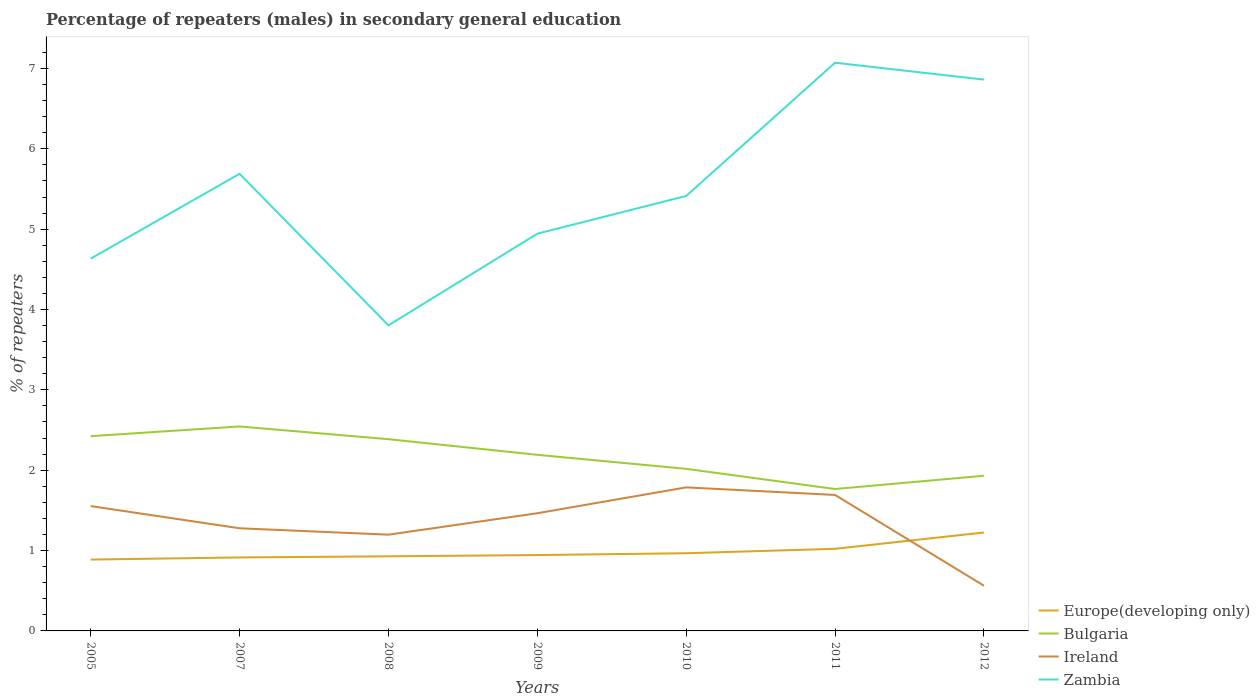How many different coloured lines are there?
Give a very brief answer. 4. Across all years, what is the maximum percentage of male repeaters in Bulgaria?
Your response must be concise. 1.77. In which year was the percentage of male repeaters in Bulgaria maximum?
Provide a short and direct response. 2011. What is the total percentage of male repeaters in Europe(developing only) in the graph?
Provide a short and direct response. -0.02. What is the difference between the highest and the second highest percentage of male repeaters in Europe(developing only)?
Ensure brevity in your answer.  0.34. Are the values on the major ticks of Y-axis written in scientific E-notation?
Offer a very short reply. No. Does the graph contain any zero values?
Keep it short and to the point. No. Where does the legend appear in the graph?
Provide a short and direct response. Bottom right. How many legend labels are there?
Provide a short and direct response. 4. How are the legend labels stacked?
Offer a very short reply. Vertical. What is the title of the graph?
Make the answer very short. Percentage of repeaters (males) in secondary general education. What is the label or title of the X-axis?
Provide a short and direct response. Years. What is the label or title of the Y-axis?
Your answer should be very brief. % of repeaters. What is the % of repeaters in Europe(developing only) in 2005?
Provide a short and direct response. 0.89. What is the % of repeaters of Bulgaria in 2005?
Keep it short and to the point. 2.42. What is the % of repeaters of Ireland in 2005?
Make the answer very short. 1.55. What is the % of repeaters in Zambia in 2005?
Provide a short and direct response. 4.63. What is the % of repeaters of Europe(developing only) in 2007?
Offer a terse response. 0.91. What is the % of repeaters of Bulgaria in 2007?
Your answer should be compact. 2.54. What is the % of repeaters of Ireland in 2007?
Ensure brevity in your answer.  1.28. What is the % of repeaters of Zambia in 2007?
Give a very brief answer. 5.69. What is the % of repeaters in Europe(developing only) in 2008?
Make the answer very short. 0.93. What is the % of repeaters in Bulgaria in 2008?
Keep it short and to the point. 2.39. What is the % of repeaters of Ireland in 2008?
Offer a terse response. 1.2. What is the % of repeaters in Zambia in 2008?
Give a very brief answer. 3.8. What is the % of repeaters in Europe(developing only) in 2009?
Provide a succinct answer. 0.94. What is the % of repeaters of Bulgaria in 2009?
Provide a succinct answer. 2.19. What is the % of repeaters of Ireland in 2009?
Your answer should be very brief. 1.46. What is the % of repeaters in Zambia in 2009?
Offer a very short reply. 4.94. What is the % of repeaters of Europe(developing only) in 2010?
Offer a very short reply. 0.97. What is the % of repeaters of Bulgaria in 2010?
Your response must be concise. 2.02. What is the % of repeaters in Ireland in 2010?
Make the answer very short. 1.79. What is the % of repeaters of Zambia in 2010?
Your response must be concise. 5.41. What is the % of repeaters in Europe(developing only) in 2011?
Offer a very short reply. 1.02. What is the % of repeaters of Bulgaria in 2011?
Your answer should be compact. 1.77. What is the % of repeaters of Ireland in 2011?
Your response must be concise. 1.69. What is the % of repeaters in Zambia in 2011?
Your answer should be compact. 7.07. What is the % of repeaters of Europe(developing only) in 2012?
Provide a short and direct response. 1.23. What is the % of repeaters of Bulgaria in 2012?
Your response must be concise. 1.93. What is the % of repeaters in Ireland in 2012?
Make the answer very short. 0.56. What is the % of repeaters in Zambia in 2012?
Make the answer very short. 6.86. Across all years, what is the maximum % of repeaters in Europe(developing only)?
Offer a very short reply. 1.23. Across all years, what is the maximum % of repeaters in Bulgaria?
Ensure brevity in your answer.  2.54. Across all years, what is the maximum % of repeaters of Ireland?
Give a very brief answer. 1.79. Across all years, what is the maximum % of repeaters of Zambia?
Your answer should be very brief. 7.07. Across all years, what is the minimum % of repeaters of Europe(developing only)?
Keep it short and to the point. 0.89. Across all years, what is the minimum % of repeaters in Bulgaria?
Keep it short and to the point. 1.77. Across all years, what is the minimum % of repeaters of Ireland?
Keep it short and to the point. 0.56. Across all years, what is the minimum % of repeaters in Zambia?
Ensure brevity in your answer.  3.8. What is the total % of repeaters in Europe(developing only) in the graph?
Your answer should be very brief. 6.89. What is the total % of repeaters in Bulgaria in the graph?
Offer a very short reply. 15.26. What is the total % of repeaters in Ireland in the graph?
Provide a short and direct response. 9.53. What is the total % of repeaters of Zambia in the graph?
Your answer should be very brief. 38.41. What is the difference between the % of repeaters of Europe(developing only) in 2005 and that in 2007?
Provide a short and direct response. -0.03. What is the difference between the % of repeaters of Bulgaria in 2005 and that in 2007?
Your response must be concise. -0.12. What is the difference between the % of repeaters of Ireland in 2005 and that in 2007?
Offer a terse response. 0.28. What is the difference between the % of repeaters in Zambia in 2005 and that in 2007?
Ensure brevity in your answer.  -1.06. What is the difference between the % of repeaters in Europe(developing only) in 2005 and that in 2008?
Give a very brief answer. -0.04. What is the difference between the % of repeaters in Bulgaria in 2005 and that in 2008?
Make the answer very short. 0.04. What is the difference between the % of repeaters in Ireland in 2005 and that in 2008?
Your response must be concise. 0.36. What is the difference between the % of repeaters in Zambia in 2005 and that in 2008?
Ensure brevity in your answer.  0.83. What is the difference between the % of repeaters of Europe(developing only) in 2005 and that in 2009?
Your answer should be very brief. -0.06. What is the difference between the % of repeaters of Bulgaria in 2005 and that in 2009?
Provide a short and direct response. 0.23. What is the difference between the % of repeaters of Ireland in 2005 and that in 2009?
Offer a terse response. 0.09. What is the difference between the % of repeaters of Zambia in 2005 and that in 2009?
Provide a succinct answer. -0.31. What is the difference between the % of repeaters in Europe(developing only) in 2005 and that in 2010?
Offer a terse response. -0.08. What is the difference between the % of repeaters in Bulgaria in 2005 and that in 2010?
Your answer should be compact. 0.41. What is the difference between the % of repeaters of Ireland in 2005 and that in 2010?
Provide a succinct answer. -0.23. What is the difference between the % of repeaters of Zambia in 2005 and that in 2010?
Provide a succinct answer. -0.78. What is the difference between the % of repeaters of Europe(developing only) in 2005 and that in 2011?
Provide a short and direct response. -0.13. What is the difference between the % of repeaters of Bulgaria in 2005 and that in 2011?
Offer a very short reply. 0.66. What is the difference between the % of repeaters in Ireland in 2005 and that in 2011?
Provide a short and direct response. -0.14. What is the difference between the % of repeaters of Zambia in 2005 and that in 2011?
Provide a short and direct response. -2.44. What is the difference between the % of repeaters in Europe(developing only) in 2005 and that in 2012?
Your answer should be very brief. -0.34. What is the difference between the % of repeaters in Bulgaria in 2005 and that in 2012?
Offer a very short reply. 0.49. What is the difference between the % of repeaters of Zambia in 2005 and that in 2012?
Your answer should be very brief. -2.23. What is the difference between the % of repeaters of Europe(developing only) in 2007 and that in 2008?
Your answer should be very brief. -0.01. What is the difference between the % of repeaters in Bulgaria in 2007 and that in 2008?
Ensure brevity in your answer.  0.16. What is the difference between the % of repeaters of Ireland in 2007 and that in 2008?
Your response must be concise. 0.08. What is the difference between the % of repeaters in Zambia in 2007 and that in 2008?
Make the answer very short. 1.89. What is the difference between the % of repeaters of Europe(developing only) in 2007 and that in 2009?
Give a very brief answer. -0.03. What is the difference between the % of repeaters in Bulgaria in 2007 and that in 2009?
Make the answer very short. 0.35. What is the difference between the % of repeaters of Ireland in 2007 and that in 2009?
Your answer should be very brief. -0.19. What is the difference between the % of repeaters in Zambia in 2007 and that in 2009?
Give a very brief answer. 0.75. What is the difference between the % of repeaters in Europe(developing only) in 2007 and that in 2010?
Your answer should be very brief. -0.05. What is the difference between the % of repeaters of Bulgaria in 2007 and that in 2010?
Your answer should be compact. 0.53. What is the difference between the % of repeaters in Ireland in 2007 and that in 2010?
Give a very brief answer. -0.51. What is the difference between the % of repeaters in Zambia in 2007 and that in 2010?
Provide a succinct answer. 0.28. What is the difference between the % of repeaters of Europe(developing only) in 2007 and that in 2011?
Give a very brief answer. -0.11. What is the difference between the % of repeaters in Bulgaria in 2007 and that in 2011?
Your answer should be compact. 0.78. What is the difference between the % of repeaters of Ireland in 2007 and that in 2011?
Your answer should be compact. -0.41. What is the difference between the % of repeaters in Zambia in 2007 and that in 2011?
Your response must be concise. -1.38. What is the difference between the % of repeaters in Europe(developing only) in 2007 and that in 2012?
Provide a short and direct response. -0.31. What is the difference between the % of repeaters of Bulgaria in 2007 and that in 2012?
Make the answer very short. 0.61. What is the difference between the % of repeaters in Ireland in 2007 and that in 2012?
Provide a succinct answer. 0.71. What is the difference between the % of repeaters in Zambia in 2007 and that in 2012?
Provide a succinct answer. -1.17. What is the difference between the % of repeaters of Europe(developing only) in 2008 and that in 2009?
Your answer should be very brief. -0.02. What is the difference between the % of repeaters in Bulgaria in 2008 and that in 2009?
Ensure brevity in your answer.  0.19. What is the difference between the % of repeaters of Ireland in 2008 and that in 2009?
Offer a very short reply. -0.27. What is the difference between the % of repeaters in Zambia in 2008 and that in 2009?
Provide a short and direct response. -1.14. What is the difference between the % of repeaters in Europe(developing only) in 2008 and that in 2010?
Your answer should be very brief. -0.04. What is the difference between the % of repeaters of Bulgaria in 2008 and that in 2010?
Keep it short and to the point. 0.37. What is the difference between the % of repeaters of Ireland in 2008 and that in 2010?
Provide a short and direct response. -0.59. What is the difference between the % of repeaters in Zambia in 2008 and that in 2010?
Provide a succinct answer. -1.61. What is the difference between the % of repeaters of Europe(developing only) in 2008 and that in 2011?
Your answer should be compact. -0.09. What is the difference between the % of repeaters of Bulgaria in 2008 and that in 2011?
Your response must be concise. 0.62. What is the difference between the % of repeaters in Ireland in 2008 and that in 2011?
Provide a short and direct response. -0.49. What is the difference between the % of repeaters of Zambia in 2008 and that in 2011?
Provide a short and direct response. -3.27. What is the difference between the % of repeaters of Europe(developing only) in 2008 and that in 2012?
Offer a terse response. -0.3. What is the difference between the % of repeaters of Bulgaria in 2008 and that in 2012?
Give a very brief answer. 0.46. What is the difference between the % of repeaters in Ireland in 2008 and that in 2012?
Your answer should be compact. 0.64. What is the difference between the % of repeaters in Zambia in 2008 and that in 2012?
Offer a terse response. -3.06. What is the difference between the % of repeaters of Europe(developing only) in 2009 and that in 2010?
Offer a terse response. -0.02. What is the difference between the % of repeaters of Bulgaria in 2009 and that in 2010?
Your answer should be compact. 0.17. What is the difference between the % of repeaters in Ireland in 2009 and that in 2010?
Ensure brevity in your answer.  -0.32. What is the difference between the % of repeaters in Zambia in 2009 and that in 2010?
Your answer should be very brief. -0.47. What is the difference between the % of repeaters in Europe(developing only) in 2009 and that in 2011?
Your answer should be compact. -0.08. What is the difference between the % of repeaters in Bulgaria in 2009 and that in 2011?
Provide a short and direct response. 0.43. What is the difference between the % of repeaters in Ireland in 2009 and that in 2011?
Make the answer very short. -0.23. What is the difference between the % of repeaters of Zambia in 2009 and that in 2011?
Give a very brief answer. -2.13. What is the difference between the % of repeaters in Europe(developing only) in 2009 and that in 2012?
Keep it short and to the point. -0.28. What is the difference between the % of repeaters of Bulgaria in 2009 and that in 2012?
Offer a very short reply. 0.26. What is the difference between the % of repeaters in Ireland in 2009 and that in 2012?
Make the answer very short. 0.9. What is the difference between the % of repeaters of Zambia in 2009 and that in 2012?
Make the answer very short. -1.92. What is the difference between the % of repeaters of Europe(developing only) in 2010 and that in 2011?
Provide a succinct answer. -0.05. What is the difference between the % of repeaters of Bulgaria in 2010 and that in 2011?
Make the answer very short. 0.25. What is the difference between the % of repeaters in Ireland in 2010 and that in 2011?
Give a very brief answer. 0.09. What is the difference between the % of repeaters in Zambia in 2010 and that in 2011?
Ensure brevity in your answer.  -1.66. What is the difference between the % of repeaters in Europe(developing only) in 2010 and that in 2012?
Offer a very short reply. -0.26. What is the difference between the % of repeaters of Bulgaria in 2010 and that in 2012?
Keep it short and to the point. 0.09. What is the difference between the % of repeaters in Ireland in 2010 and that in 2012?
Ensure brevity in your answer.  1.22. What is the difference between the % of repeaters of Zambia in 2010 and that in 2012?
Give a very brief answer. -1.45. What is the difference between the % of repeaters in Europe(developing only) in 2011 and that in 2012?
Provide a short and direct response. -0.2. What is the difference between the % of repeaters in Bulgaria in 2011 and that in 2012?
Your response must be concise. -0.16. What is the difference between the % of repeaters of Ireland in 2011 and that in 2012?
Give a very brief answer. 1.13. What is the difference between the % of repeaters of Zambia in 2011 and that in 2012?
Make the answer very short. 0.21. What is the difference between the % of repeaters of Europe(developing only) in 2005 and the % of repeaters of Bulgaria in 2007?
Your response must be concise. -1.66. What is the difference between the % of repeaters in Europe(developing only) in 2005 and the % of repeaters in Ireland in 2007?
Keep it short and to the point. -0.39. What is the difference between the % of repeaters in Europe(developing only) in 2005 and the % of repeaters in Zambia in 2007?
Ensure brevity in your answer.  -4.8. What is the difference between the % of repeaters of Bulgaria in 2005 and the % of repeaters of Ireland in 2007?
Make the answer very short. 1.15. What is the difference between the % of repeaters in Bulgaria in 2005 and the % of repeaters in Zambia in 2007?
Offer a very short reply. -3.26. What is the difference between the % of repeaters in Ireland in 2005 and the % of repeaters in Zambia in 2007?
Provide a short and direct response. -4.13. What is the difference between the % of repeaters of Europe(developing only) in 2005 and the % of repeaters of Bulgaria in 2008?
Your response must be concise. -1.5. What is the difference between the % of repeaters of Europe(developing only) in 2005 and the % of repeaters of Ireland in 2008?
Give a very brief answer. -0.31. What is the difference between the % of repeaters of Europe(developing only) in 2005 and the % of repeaters of Zambia in 2008?
Make the answer very short. -2.91. What is the difference between the % of repeaters of Bulgaria in 2005 and the % of repeaters of Ireland in 2008?
Your answer should be very brief. 1.23. What is the difference between the % of repeaters in Bulgaria in 2005 and the % of repeaters in Zambia in 2008?
Your answer should be very brief. -1.38. What is the difference between the % of repeaters in Ireland in 2005 and the % of repeaters in Zambia in 2008?
Ensure brevity in your answer.  -2.25. What is the difference between the % of repeaters in Europe(developing only) in 2005 and the % of repeaters in Bulgaria in 2009?
Keep it short and to the point. -1.3. What is the difference between the % of repeaters of Europe(developing only) in 2005 and the % of repeaters of Ireland in 2009?
Ensure brevity in your answer.  -0.58. What is the difference between the % of repeaters in Europe(developing only) in 2005 and the % of repeaters in Zambia in 2009?
Give a very brief answer. -4.06. What is the difference between the % of repeaters of Bulgaria in 2005 and the % of repeaters of Ireland in 2009?
Give a very brief answer. 0.96. What is the difference between the % of repeaters of Bulgaria in 2005 and the % of repeaters of Zambia in 2009?
Provide a succinct answer. -2.52. What is the difference between the % of repeaters of Ireland in 2005 and the % of repeaters of Zambia in 2009?
Your answer should be very brief. -3.39. What is the difference between the % of repeaters of Europe(developing only) in 2005 and the % of repeaters of Bulgaria in 2010?
Give a very brief answer. -1.13. What is the difference between the % of repeaters in Europe(developing only) in 2005 and the % of repeaters in Ireland in 2010?
Give a very brief answer. -0.9. What is the difference between the % of repeaters in Europe(developing only) in 2005 and the % of repeaters in Zambia in 2010?
Provide a short and direct response. -4.53. What is the difference between the % of repeaters in Bulgaria in 2005 and the % of repeaters in Ireland in 2010?
Your response must be concise. 0.64. What is the difference between the % of repeaters of Bulgaria in 2005 and the % of repeaters of Zambia in 2010?
Offer a very short reply. -2.99. What is the difference between the % of repeaters of Ireland in 2005 and the % of repeaters of Zambia in 2010?
Make the answer very short. -3.86. What is the difference between the % of repeaters in Europe(developing only) in 2005 and the % of repeaters in Bulgaria in 2011?
Provide a short and direct response. -0.88. What is the difference between the % of repeaters of Europe(developing only) in 2005 and the % of repeaters of Ireland in 2011?
Your response must be concise. -0.8. What is the difference between the % of repeaters in Europe(developing only) in 2005 and the % of repeaters in Zambia in 2011?
Your answer should be compact. -6.18. What is the difference between the % of repeaters in Bulgaria in 2005 and the % of repeaters in Ireland in 2011?
Offer a terse response. 0.73. What is the difference between the % of repeaters of Bulgaria in 2005 and the % of repeaters of Zambia in 2011?
Give a very brief answer. -4.65. What is the difference between the % of repeaters of Ireland in 2005 and the % of repeaters of Zambia in 2011?
Make the answer very short. -5.52. What is the difference between the % of repeaters in Europe(developing only) in 2005 and the % of repeaters in Bulgaria in 2012?
Keep it short and to the point. -1.04. What is the difference between the % of repeaters of Europe(developing only) in 2005 and the % of repeaters of Ireland in 2012?
Your answer should be very brief. 0.33. What is the difference between the % of repeaters in Europe(developing only) in 2005 and the % of repeaters in Zambia in 2012?
Your answer should be very brief. -5.97. What is the difference between the % of repeaters of Bulgaria in 2005 and the % of repeaters of Ireland in 2012?
Give a very brief answer. 1.86. What is the difference between the % of repeaters of Bulgaria in 2005 and the % of repeaters of Zambia in 2012?
Your response must be concise. -4.44. What is the difference between the % of repeaters in Ireland in 2005 and the % of repeaters in Zambia in 2012?
Provide a short and direct response. -5.31. What is the difference between the % of repeaters in Europe(developing only) in 2007 and the % of repeaters in Bulgaria in 2008?
Make the answer very short. -1.47. What is the difference between the % of repeaters in Europe(developing only) in 2007 and the % of repeaters in Ireland in 2008?
Keep it short and to the point. -0.28. What is the difference between the % of repeaters in Europe(developing only) in 2007 and the % of repeaters in Zambia in 2008?
Offer a terse response. -2.89. What is the difference between the % of repeaters in Bulgaria in 2007 and the % of repeaters in Ireland in 2008?
Offer a very short reply. 1.35. What is the difference between the % of repeaters of Bulgaria in 2007 and the % of repeaters of Zambia in 2008?
Offer a very short reply. -1.26. What is the difference between the % of repeaters of Ireland in 2007 and the % of repeaters of Zambia in 2008?
Your response must be concise. -2.53. What is the difference between the % of repeaters of Europe(developing only) in 2007 and the % of repeaters of Bulgaria in 2009?
Offer a very short reply. -1.28. What is the difference between the % of repeaters of Europe(developing only) in 2007 and the % of repeaters of Ireland in 2009?
Provide a short and direct response. -0.55. What is the difference between the % of repeaters of Europe(developing only) in 2007 and the % of repeaters of Zambia in 2009?
Provide a succinct answer. -4.03. What is the difference between the % of repeaters of Bulgaria in 2007 and the % of repeaters of Zambia in 2009?
Ensure brevity in your answer.  -2.4. What is the difference between the % of repeaters of Ireland in 2007 and the % of repeaters of Zambia in 2009?
Ensure brevity in your answer.  -3.67. What is the difference between the % of repeaters in Europe(developing only) in 2007 and the % of repeaters in Bulgaria in 2010?
Provide a succinct answer. -1.1. What is the difference between the % of repeaters of Europe(developing only) in 2007 and the % of repeaters of Ireland in 2010?
Offer a terse response. -0.87. What is the difference between the % of repeaters of Europe(developing only) in 2007 and the % of repeaters of Zambia in 2010?
Provide a short and direct response. -4.5. What is the difference between the % of repeaters in Bulgaria in 2007 and the % of repeaters in Ireland in 2010?
Offer a very short reply. 0.76. What is the difference between the % of repeaters of Bulgaria in 2007 and the % of repeaters of Zambia in 2010?
Your response must be concise. -2.87. What is the difference between the % of repeaters of Ireland in 2007 and the % of repeaters of Zambia in 2010?
Keep it short and to the point. -4.14. What is the difference between the % of repeaters in Europe(developing only) in 2007 and the % of repeaters in Bulgaria in 2011?
Keep it short and to the point. -0.85. What is the difference between the % of repeaters in Europe(developing only) in 2007 and the % of repeaters in Ireland in 2011?
Your answer should be very brief. -0.78. What is the difference between the % of repeaters of Europe(developing only) in 2007 and the % of repeaters of Zambia in 2011?
Make the answer very short. -6.16. What is the difference between the % of repeaters in Bulgaria in 2007 and the % of repeaters in Ireland in 2011?
Your response must be concise. 0.85. What is the difference between the % of repeaters of Bulgaria in 2007 and the % of repeaters of Zambia in 2011?
Provide a short and direct response. -4.53. What is the difference between the % of repeaters of Ireland in 2007 and the % of repeaters of Zambia in 2011?
Your answer should be compact. -5.79. What is the difference between the % of repeaters in Europe(developing only) in 2007 and the % of repeaters in Bulgaria in 2012?
Offer a very short reply. -1.02. What is the difference between the % of repeaters of Europe(developing only) in 2007 and the % of repeaters of Ireland in 2012?
Offer a terse response. 0.35. What is the difference between the % of repeaters of Europe(developing only) in 2007 and the % of repeaters of Zambia in 2012?
Provide a succinct answer. -5.95. What is the difference between the % of repeaters in Bulgaria in 2007 and the % of repeaters in Ireland in 2012?
Provide a succinct answer. 1.98. What is the difference between the % of repeaters in Bulgaria in 2007 and the % of repeaters in Zambia in 2012?
Make the answer very short. -4.32. What is the difference between the % of repeaters in Ireland in 2007 and the % of repeaters in Zambia in 2012?
Provide a succinct answer. -5.58. What is the difference between the % of repeaters of Europe(developing only) in 2008 and the % of repeaters of Bulgaria in 2009?
Provide a short and direct response. -1.26. What is the difference between the % of repeaters of Europe(developing only) in 2008 and the % of repeaters of Ireland in 2009?
Your response must be concise. -0.54. What is the difference between the % of repeaters of Europe(developing only) in 2008 and the % of repeaters of Zambia in 2009?
Offer a terse response. -4.01. What is the difference between the % of repeaters in Bulgaria in 2008 and the % of repeaters in Ireland in 2009?
Provide a succinct answer. 0.92. What is the difference between the % of repeaters of Bulgaria in 2008 and the % of repeaters of Zambia in 2009?
Offer a very short reply. -2.56. What is the difference between the % of repeaters in Ireland in 2008 and the % of repeaters in Zambia in 2009?
Your answer should be compact. -3.75. What is the difference between the % of repeaters of Europe(developing only) in 2008 and the % of repeaters of Bulgaria in 2010?
Your response must be concise. -1.09. What is the difference between the % of repeaters of Europe(developing only) in 2008 and the % of repeaters of Ireland in 2010?
Offer a very short reply. -0.86. What is the difference between the % of repeaters in Europe(developing only) in 2008 and the % of repeaters in Zambia in 2010?
Keep it short and to the point. -4.48. What is the difference between the % of repeaters in Bulgaria in 2008 and the % of repeaters in Ireland in 2010?
Your response must be concise. 0.6. What is the difference between the % of repeaters of Bulgaria in 2008 and the % of repeaters of Zambia in 2010?
Provide a short and direct response. -3.03. What is the difference between the % of repeaters of Ireland in 2008 and the % of repeaters of Zambia in 2010?
Your response must be concise. -4.22. What is the difference between the % of repeaters in Europe(developing only) in 2008 and the % of repeaters in Bulgaria in 2011?
Your answer should be compact. -0.84. What is the difference between the % of repeaters in Europe(developing only) in 2008 and the % of repeaters in Ireland in 2011?
Offer a terse response. -0.76. What is the difference between the % of repeaters in Europe(developing only) in 2008 and the % of repeaters in Zambia in 2011?
Keep it short and to the point. -6.14. What is the difference between the % of repeaters of Bulgaria in 2008 and the % of repeaters of Ireland in 2011?
Your response must be concise. 0.69. What is the difference between the % of repeaters of Bulgaria in 2008 and the % of repeaters of Zambia in 2011?
Your response must be concise. -4.68. What is the difference between the % of repeaters in Ireland in 2008 and the % of repeaters in Zambia in 2011?
Ensure brevity in your answer.  -5.87. What is the difference between the % of repeaters in Europe(developing only) in 2008 and the % of repeaters in Bulgaria in 2012?
Make the answer very short. -1. What is the difference between the % of repeaters of Europe(developing only) in 2008 and the % of repeaters of Ireland in 2012?
Give a very brief answer. 0.37. What is the difference between the % of repeaters of Europe(developing only) in 2008 and the % of repeaters of Zambia in 2012?
Provide a succinct answer. -5.93. What is the difference between the % of repeaters in Bulgaria in 2008 and the % of repeaters in Ireland in 2012?
Give a very brief answer. 1.82. What is the difference between the % of repeaters in Bulgaria in 2008 and the % of repeaters in Zambia in 2012?
Offer a terse response. -4.47. What is the difference between the % of repeaters of Ireland in 2008 and the % of repeaters of Zambia in 2012?
Offer a terse response. -5.66. What is the difference between the % of repeaters of Europe(developing only) in 2009 and the % of repeaters of Bulgaria in 2010?
Offer a very short reply. -1.07. What is the difference between the % of repeaters of Europe(developing only) in 2009 and the % of repeaters of Ireland in 2010?
Provide a short and direct response. -0.84. What is the difference between the % of repeaters in Europe(developing only) in 2009 and the % of repeaters in Zambia in 2010?
Provide a succinct answer. -4.47. What is the difference between the % of repeaters in Bulgaria in 2009 and the % of repeaters in Ireland in 2010?
Your answer should be compact. 0.41. What is the difference between the % of repeaters of Bulgaria in 2009 and the % of repeaters of Zambia in 2010?
Give a very brief answer. -3.22. What is the difference between the % of repeaters in Ireland in 2009 and the % of repeaters in Zambia in 2010?
Offer a terse response. -3.95. What is the difference between the % of repeaters of Europe(developing only) in 2009 and the % of repeaters of Bulgaria in 2011?
Provide a short and direct response. -0.82. What is the difference between the % of repeaters in Europe(developing only) in 2009 and the % of repeaters in Ireland in 2011?
Provide a short and direct response. -0.75. What is the difference between the % of repeaters of Europe(developing only) in 2009 and the % of repeaters of Zambia in 2011?
Provide a succinct answer. -6.13. What is the difference between the % of repeaters in Bulgaria in 2009 and the % of repeaters in Ireland in 2011?
Offer a very short reply. 0.5. What is the difference between the % of repeaters in Bulgaria in 2009 and the % of repeaters in Zambia in 2011?
Your answer should be compact. -4.88. What is the difference between the % of repeaters of Ireland in 2009 and the % of repeaters of Zambia in 2011?
Offer a terse response. -5.61. What is the difference between the % of repeaters of Europe(developing only) in 2009 and the % of repeaters of Bulgaria in 2012?
Your answer should be compact. -0.99. What is the difference between the % of repeaters in Europe(developing only) in 2009 and the % of repeaters in Ireland in 2012?
Your answer should be compact. 0.38. What is the difference between the % of repeaters in Europe(developing only) in 2009 and the % of repeaters in Zambia in 2012?
Provide a short and direct response. -5.92. What is the difference between the % of repeaters in Bulgaria in 2009 and the % of repeaters in Ireland in 2012?
Offer a terse response. 1.63. What is the difference between the % of repeaters in Bulgaria in 2009 and the % of repeaters in Zambia in 2012?
Provide a succinct answer. -4.67. What is the difference between the % of repeaters of Ireland in 2009 and the % of repeaters of Zambia in 2012?
Your answer should be very brief. -5.4. What is the difference between the % of repeaters of Europe(developing only) in 2010 and the % of repeaters of Bulgaria in 2011?
Your answer should be very brief. -0.8. What is the difference between the % of repeaters in Europe(developing only) in 2010 and the % of repeaters in Ireland in 2011?
Provide a succinct answer. -0.73. What is the difference between the % of repeaters in Europe(developing only) in 2010 and the % of repeaters in Zambia in 2011?
Provide a short and direct response. -6.1. What is the difference between the % of repeaters in Bulgaria in 2010 and the % of repeaters in Ireland in 2011?
Provide a short and direct response. 0.33. What is the difference between the % of repeaters of Bulgaria in 2010 and the % of repeaters of Zambia in 2011?
Your answer should be compact. -5.05. What is the difference between the % of repeaters of Ireland in 2010 and the % of repeaters of Zambia in 2011?
Keep it short and to the point. -5.28. What is the difference between the % of repeaters of Europe(developing only) in 2010 and the % of repeaters of Bulgaria in 2012?
Your answer should be compact. -0.96. What is the difference between the % of repeaters in Europe(developing only) in 2010 and the % of repeaters in Ireland in 2012?
Your answer should be compact. 0.4. What is the difference between the % of repeaters in Europe(developing only) in 2010 and the % of repeaters in Zambia in 2012?
Ensure brevity in your answer.  -5.89. What is the difference between the % of repeaters in Bulgaria in 2010 and the % of repeaters in Ireland in 2012?
Provide a short and direct response. 1.45. What is the difference between the % of repeaters of Bulgaria in 2010 and the % of repeaters of Zambia in 2012?
Your answer should be very brief. -4.84. What is the difference between the % of repeaters in Ireland in 2010 and the % of repeaters in Zambia in 2012?
Offer a very short reply. -5.07. What is the difference between the % of repeaters in Europe(developing only) in 2011 and the % of repeaters in Bulgaria in 2012?
Provide a succinct answer. -0.91. What is the difference between the % of repeaters of Europe(developing only) in 2011 and the % of repeaters of Ireland in 2012?
Offer a terse response. 0.46. What is the difference between the % of repeaters of Europe(developing only) in 2011 and the % of repeaters of Zambia in 2012?
Offer a very short reply. -5.84. What is the difference between the % of repeaters of Bulgaria in 2011 and the % of repeaters of Ireland in 2012?
Provide a succinct answer. 1.2. What is the difference between the % of repeaters of Bulgaria in 2011 and the % of repeaters of Zambia in 2012?
Make the answer very short. -5.09. What is the difference between the % of repeaters in Ireland in 2011 and the % of repeaters in Zambia in 2012?
Give a very brief answer. -5.17. What is the average % of repeaters of Europe(developing only) per year?
Keep it short and to the point. 0.98. What is the average % of repeaters of Bulgaria per year?
Offer a terse response. 2.18. What is the average % of repeaters of Ireland per year?
Ensure brevity in your answer.  1.36. What is the average % of repeaters of Zambia per year?
Your answer should be very brief. 5.49. In the year 2005, what is the difference between the % of repeaters of Europe(developing only) and % of repeaters of Bulgaria?
Your answer should be very brief. -1.54. In the year 2005, what is the difference between the % of repeaters of Europe(developing only) and % of repeaters of Ireland?
Offer a terse response. -0.67. In the year 2005, what is the difference between the % of repeaters of Europe(developing only) and % of repeaters of Zambia?
Offer a terse response. -3.75. In the year 2005, what is the difference between the % of repeaters of Bulgaria and % of repeaters of Ireland?
Make the answer very short. 0.87. In the year 2005, what is the difference between the % of repeaters of Bulgaria and % of repeaters of Zambia?
Your answer should be very brief. -2.21. In the year 2005, what is the difference between the % of repeaters of Ireland and % of repeaters of Zambia?
Give a very brief answer. -3.08. In the year 2007, what is the difference between the % of repeaters in Europe(developing only) and % of repeaters in Bulgaria?
Offer a terse response. -1.63. In the year 2007, what is the difference between the % of repeaters in Europe(developing only) and % of repeaters in Ireland?
Give a very brief answer. -0.36. In the year 2007, what is the difference between the % of repeaters in Europe(developing only) and % of repeaters in Zambia?
Your response must be concise. -4.77. In the year 2007, what is the difference between the % of repeaters in Bulgaria and % of repeaters in Ireland?
Make the answer very short. 1.27. In the year 2007, what is the difference between the % of repeaters of Bulgaria and % of repeaters of Zambia?
Provide a short and direct response. -3.14. In the year 2007, what is the difference between the % of repeaters of Ireland and % of repeaters of Zambia?
Offer a very short reply. -4.41. In the year 2008, what is the difference between the % of repeaters in Europe(developing only) and % of repeaters in Bulgaria?
Give a very brief answer. -1.46. In the year 2008, what is the difference between the % of repeaters of Europe(developing only) and % of repeaters of Ireland?
Give a very brief answer. -0.27. In the year 2008, what is the difference between the % of repeaters in Europe(developing only) and % of repeaters in Zambia?
Your response must be concise. -2.87. In the year 2008, what is the difference between the % of repeaters of Bulgaria and % of repeaters of Ireland?
Your response must be concise. 1.19. In the year 2008, what is the difference between the % of repeaters in Bulgaria and % of repeaters in Zambia?
Give a very brief answer. -1.42. In the year 2008, what is the difference between the % of repeaters in Ireland and % of repeaters in Zambia?
Offer a very short reply. -2.6. In the year 2009, what is the difference between the % of repeaters in Europe(developing only) and % of repeaters in Bulgaria?
Offer a very short reply. -1.25. In the year 2009, what is the difference between the % of repeaters of Europe(developing only) and % of repeaters of Ireland?
Ensure brevity in your answer.  -0.52. In the year 2009, what is the difference between the % of repeaters of Europe(developing only) and % of repeaters of Zambia?
Your answer should be compact. -4. In the year 2009, what is the difference between the % of repeaters in Bulgaria and % of repeaters in Ireland?
Make the answer very short. 0.73. In the year 2009, what is the difference between the % of repeaters of Bulgaria and % of repeaters of Zambia?
Provide a short and direct response. -2.75. In the year 2009, what is the difference between the % of repeaters of Ireland and % of repeaters of Zambia?
Offer a terse response. -3.48. In the year 2010, what is the difference between the % of repeaters in Europe(developing only) and % of repeaters in Bulgaria?
Give a very brief answer. -1.05. In the year 2010, what is the difference between the % of repeaters in Europe(developing only) and % of repeaters in Ireland?
Your response must be concise. -0.82. In the year 2010, what is the difference between the % of repeaters in Europe(developing only) and % of repeaters in Zambia?
Your response must be concise. -4.45. In the year 2010, what is the difference between the % of repeaters in Bulgaria and % of repeaters in Ireland?
Your answer should be very brief. 0.23. In the year 2010, what is the difference between the % of repeaters in Bulgaria and % of repeaters in Zambia?
Ensure brevity in your answer.  -3.4. In the year 2010, what is the difference between the % of repeaters in Ireland and % of repeaters in Zambia?
Keep it short and to the point. -3.63. In the year 2011, what is the difference between the % of repeaters of Europe(developing only) and % of repeaters of Bulgaria?
Keep it short and to the point. -0.74. In the year 2011, what is the difference between the % of repeaters in Europe(developing only) and % of repeaters in Ireland?
Make the answer very short. -0.67. In the year 2011, what is the difference between the % of repeaters of Europe(developing only) and % of repeaters of Zambia?
Your response must be concise. -6.05. In the year 2011, what is the difference between the % of repeaters in Bulgaria and % of repeaters in Ireland?
Offer a terse response. 0.07. In the year 2011, what is the difference between the % of repeaters in Bulgaria and % of repeaters in Zambia?
Ensure brevity in your answer.  -5.3. In the year 2011, what is the difference between the % of repeaters in Ireland and % of repeaters in Zambia?
Provide a succinct answer. -5.38. In the year 2012, what is the difference between the % of repeaters in Europe(developing only) and % of repeaters in Bulgaria?
Give a very brief answer. -0.71. In the year 2012, what is the difference between the % of repeaters of Europe(developing only) and % of repeaters of Ireland?
Offer a terse response. 0.66. In the year 2012, what is the difference between the % of repeaters in Europe(developing only) and % of repeaters in Zambia?
Offer a terse response. -5.64. In the year 2012, what is the difference between the % of repeaters of Bulgaria and % of repeaters of Ireland?
Keep it short and to the point. 1.37. In the year 2012, what is the difference between the % of repeaters in Bulgaria and % of repeaters in Zambia?
Provide a succinct answer. -4.93. In the year 2012, what is the difference between the % of repeaters in Ireland and % of repeaters in Zambia?
Your answer should be very brief. -6.3. What is the ratio of the % of repeaters of Bulgaria in 2005 to that in 2007?
Offer a very short reply. 0.95. What is the ratio of the % of repeaters in Ireland in 2005 to that in 2007?
Your answer should be very brief. 1.22. What is the ratio of the % of repeaters in Zambia in 2005 to that in 2007?
Your answer should be compact. 0.81. What is the ratio of the % of repeaters of Europe(developing only) in 2005 to that in 2008?
Make the answer very short. 0.96. What is the ratio of the % of repeaters in Bulgaria in 2005 to that in 2008?
Your answer should be compact. 1.02. What is the ratio of the % of repeaters in Ireland in 2005 to that in 2008?
Offer a terse response. 1.3. What is the ratio of the % of repeaters in Zambia in 2005 to that in 2008?
Give a very brief answer. 1.22. What is the ratio of the % of repeaters in Europe(developing only) in 2005 to that in 2009?
Your answer should be very brief. 0.94. What is the ratio of the % of repeaters of Bulgaria in 2005 to that in 2009?
Your answer should be very brief. 1.11. What is the ratio of the % of repeaters of Ireland in 2005 to that in 2009?
Provide a short and direct response. 1.06. What is the ratio of the % of repeaters in Zambia in 2005 to that in 2009?
Your response must be concise. 0.94. What is the ratio of the % of repeaters of Europe(developing only) in 2005 to that in 2010?
Your answer should be compact. 0.92. What is the ratio of the % of repeaters of Bulgaria in 2005 to that in 2010?
Make the answer very short. 1.2. What is the ratio of the % of repeaters of Ireland in 2005 to that in 2010?
Your answer should be compact. 0.87. What is the ratio of the % of repeaters of Zambia in 2005 to that in 2010?
Your answer should be very brief. 0.86. What is the ratio of the % of repeaters in Europe(developing only) in 2005 to that in 2011?
Keep it short and to the point. 0.87. What is the ratio of the % of repeaters of Bulgaria in 2005 to that in 2011?
Give a very brief answer. 1.37. What is the ratio of the % of repeaters of Ireland in 2005 to that in 2011?
Make the answer very short. 0.92. What is the ratio of the % of repeaters of Zambia in 2005 to that in 2011?
Provide a short and direct response. 0.66. What is the ratio of the % of repeaters of Europe(developing only) in 2005 to that in 2012?
Provide a short and direct response. 0.72. What is the ratio of the % of repeaters in Bulgaria in 2005 to that in 2012?
Ensure brevity in your answer.  1.26. What is the ratio of the % of repeaters of Ireland in 2005 to that in 2012?
Keep it short and to the point. 2.76. What is the ratio of the % of repeaters in Zambia in 2005 to that in 2012?
Offer a very short reply. 0.68. What is the ratio of the % of repeaters of Bulgaria in 2007 to that in 2008?
Provide a succinct answer. 1.07. What is the ratio of the % of repeaters in Ireland in 2007 to that in 2008?
Your answer should be very brief. 1.07. What is the ratio of the % of repeaters of Zambia in 2007 to that in 2008?
Your response must be concise. 1.5. What is the ratio of the % of repeaters in Europe(developing only) in 2007 to that in 2009?
Give a very brief answer. 0.97. What is the ratio of the % of repeaters in Bulgaria in 2007 to that in 2009?
Your response must be concise. 1.16. What is the ratio of the % of repeaters of Ireland in 2007 to that in 2009?
Your answer should be very brief. 0.87. What is the ratio of the % of repeaters in Zambia in 2007 to that in 2009?
Offer a terse response. 1.15. What is the ratio of the % of repeaters of Europe(developing only) in 2007 to that in 2010?
Your answer should be very brief. 0.95. What is the ratio of the % of repeaters of Bulgaria in 2007 to that in 2010?
Ensure brevity in your answer.  1.26. What is the ratio of the % of repeaters in Ireland in 2007 to that in 2010?
Your answer should be very brief. 0.72. What is the ratio of the % of repeaters of Zambia in 2007 to that in 2010?
Give a very brief answer. 1.05. What is the ratio of the % of repeaters in Europe(developing only) in 2007 to that in 2011?
Your response must be concise. 0.9. What is the ratio of the % of repeaters of Bulgaria in 2007 to that in 2011?
Your answer should be compact. 1.44. What is the ratio of the % of repeaters in Ireland in 2007 to that in 2011?
Offer a terse response. 0.75. What is the ratio of the % of repeaters of Zambia in 2007 to that in 2011?
Make the answer very short. 0.8. What is the ratio of the % of repeaters in Europe(developing only) in 2007 to that in 2012?
Give a very brief answer. 0.75. What is the ratio of the % of repeaters in Bulgaria in 2007 to that in 2012?
Your answer should be very brief. 1.32. What is the ratio of the % of repeaters in Ireland in 2007 to that in 2012?
Make the answer very short. 2.27. What is the ratio of the % of repeaters of Zambia in 2007 to that in 2012?
Your answer should be very brief. 0.83. What is the ratio of the % of repeaters in Europe(developing only) in 2008 to that in 2009?
Provide a short and direct response. 0.98. What is the ratio of the % of repeaters of Bulgaria in 2008 to that in 2009?
Give a very brief answer. 1.09. What is the ratio of the % of repeaters in Ireland in 2008 to that in 2009?
Ensure brevity in your answer.  0.82. What is the ratio of the % of repeaters of Zambia in 2008 to that in 2009?
Offer a terse response. 0.77. What is the ratio of the % of repeaters of Europe(developing only) in 2008 to that in 2010?
Give a very brief answer. 0.96. What is the ratio of the % of repeaters in Bulgaria in 2008 to that in 2010?
Your answer should be very brief. 1.18. What is the ratio of the % of repeaters in Ireland in 2008 to that in 2010?
Your response must be concise. 0.67. What is the ratio of the % of repeaters of Zambia in 2008 to that in 2010?
Ensure brevity in your answer.  0.7. What is the ratio of the % of repeaters in Europe(developing only) in 2008 to that in 2011?
Offer a very short reply. 0.91. What is the ratio of the % of repeaters of Bulgaria in 2008 to that in 2011?
Provide a short and direct response. 1.35. What is the ratio of the % of repeaters of Ireland in 2008 to that in 2011?
Provide a short and direct response. 0.71. What is the ratio of the % of repeaters in Zambia in 2008 to that in 2011?
Your response must be concise. 0.54. What is the ratio of the % of repeaters in Europe(developing only) in 2008 to that in 2012?
Provide a short and direct response. 0.76. What is the ratio of the % of repeaters in Bulgaria in 2008 to that in 2012?
Provide a succinct answer. 1.24. What is the ratio of the % of repeaters of Ireland in 2008 to that in 2012?
Your answer should be very brief. 2.13. What is the ratio of the % of repeaters in Zambia in 2008 to that in 2012?
Keep it short and to the point. 0.55. What is the ratio of the % of repeaters in Europe(developing only) in 2009 to that in 2010?
Make the answer very short. 0.98. What is the ratio of the % of repeaters of Bulgaria in 2009 to that in 2010?
Your answer should be very brief. 1.09. What is the ratio of the % of repeaters of Ireland in 2009 to that in 2010?
Ensure brevity in your answer.  0.82. What is the ratio of the % of repeaters of Zambia in 2009 to that in 2010?
Offer a terse response. 0.91. What is the ratio of the % of repeaters in Europe(developing only) in 2009 to that in 2011?
Your answer should be compact. 0.92. What is the ratio of the % of repeaters of Bulgaria in 2009 to that in 2011?
Your answer should be compact. 1.24. What is the ratio of the % of repeaters of Ireland in 2009 to that in 2011?
Offer a terse response. 0.87. What is the ratio of the % of repeaters in Zambia in 2009 to that in 2011?
Make the answer very short. 0.7. What is the ratio of the % of repeaters of Europe(developing only) in 2009 to that in 2012?
Offer a very short reply. 0.77. What is the ratio of the % of repeaters of Bulgaria in 2009 to that in 2012?
Your answer should be compact. 1.13. What is the ratio of the % of repeaters in Ireland in 2009 to that in 2012?
Offer a very short reply. 2.6. What is the ratio of the % of repeaters in Zambia in 2009 to that in 2012?
Give a very brief answer. 0.72. What is the ratio of the % of repeaters of Europe(developing only) in 2010 to that in 2011?
Your response must be concise. 0.95. What is the ratio of the % of repeaters in Bulgaria in 2010 to that in 2011?
Offer a very short reply. 1.14. What is the ratio of the % of repeaters of Ireland in 2010 to that in 2011?
Offer a very short reply. 1.06. What is the ratio of the % of repeaters in Zambia in 2010 to that in 2011?
Ensure brevity in your answer.  0.77. What is the ratio of the % of repeaters in Europe(developing only) in 2010 to that in 2012?
Your answer should be very brief. 0.79. What is the ratio of the % of repeaters in Bulgaria in 2010 to that in 2012?
Provide a short and direct response. 1.04. What is the ratio of the % of repeaters of Ireland in 2010 to that in 2012?
Ensure brevity in your answer.  3.18. What is the ratio of the % of repeaters in Zambia in 2010 to that in 2012?
Offer a terse response. 0.79. What is the ratio of the % of repeaters of Europe(developing only) in 2011 to that in 2012?
Make the answer very short. 0.83. What is the ratio of the % of repeaters in Bulgaria in 2011 to that in 2012?
Give a very brief answer. 0.91. What is the ratio of the % of repeaters of Ireland in 2011 to that in 2012?
Your answer should be very brief. 3.01. What is the ratio of the % of repeaters in Zambia in 2011 to that in 2012?
Your answer should be very brief. 1.03. What is the difference between the highest and the second highest % of repeaters of Europe(developing only)?
Your answer should be very brief. 0.2. What is the difference between the highest and the second highest % of repeaters of Bulgaria?
Ensure brevity in your answer.  0.12. What is the difference between the highest and the second highest % of repeaters of Ireland?
Offer a very short reply. 0.09. What is the difference between the highest and the second highest % of repeaters in Zambia?
Your response must be concise. 0.21. What is the difference between the highest and the lowest % of repeaters of Europe(developing only)?
Your answer should be compact. 0.34. What is the difference between the highest and the lowest % of repeaters of Bulgaria?
Provide a short and direct response. 0.78. What is the difference between the highest and the lowest % of repeaters of Ireland?
Offer a very short reply. 1.22. What is the difference between the highest and the lowest % of repeaters in Zambia?
Give a very brief answer. 3.27. 